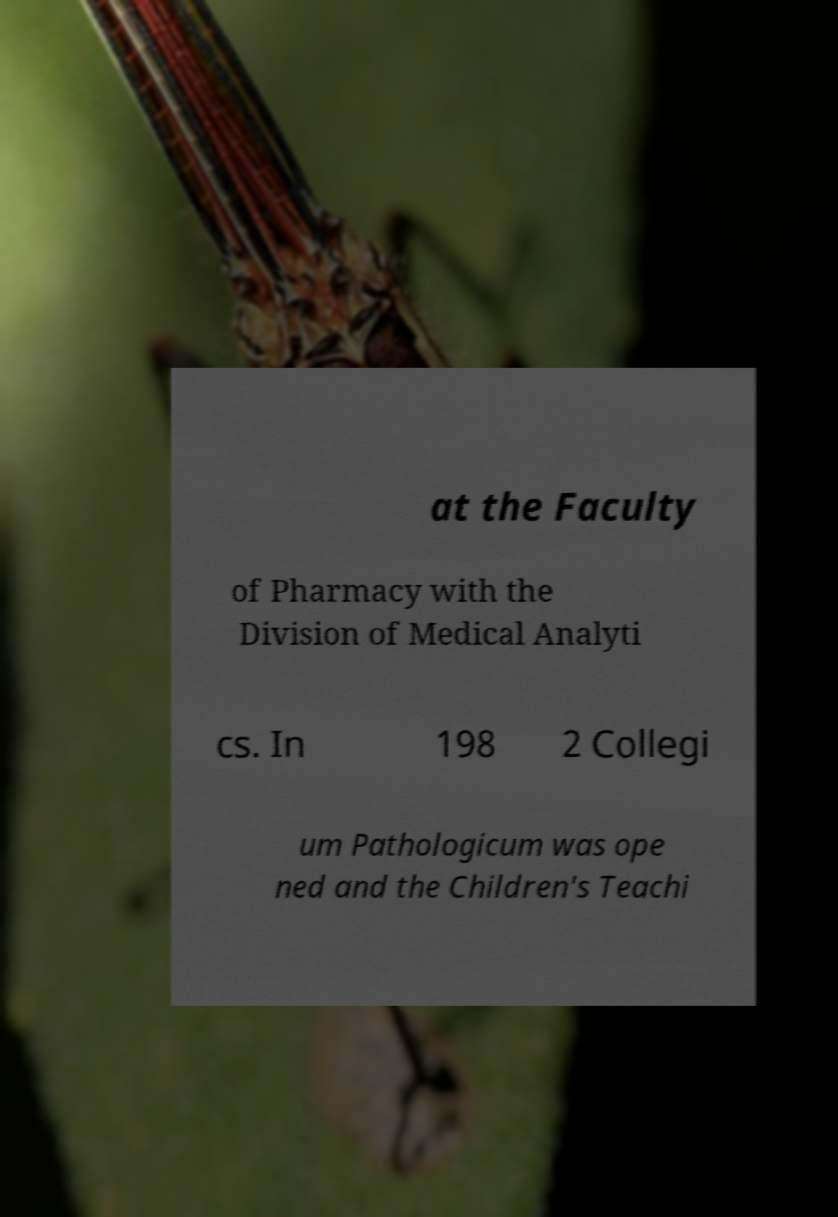Please read and relay the text visible in this image. What does it say? at the Faculty of Pharmacy with the Division of Medical Analyti cs. In 198 2 Collegi um Pathologicum was ope ned and the Children's Teachi 